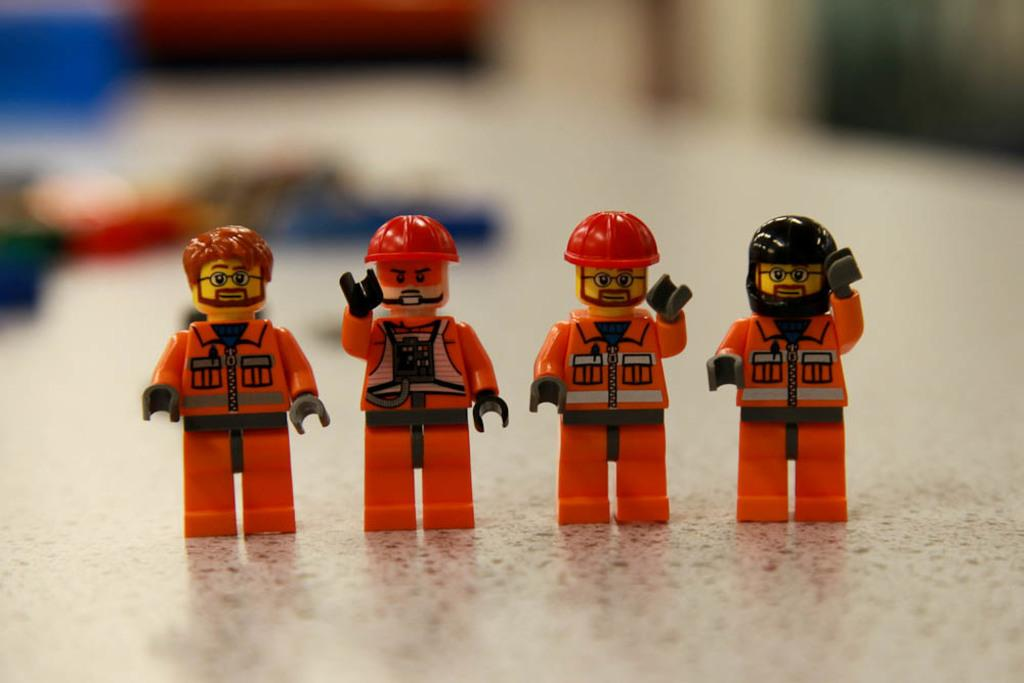What is located in the middle of the image? There are toys in the middle of the image. Can you describe the background of the image? The background of the image is blurry. What type of adjustment is being made by the laborer in the image? There is no laborer present in the image, and therefore no adjustment can be observed. 